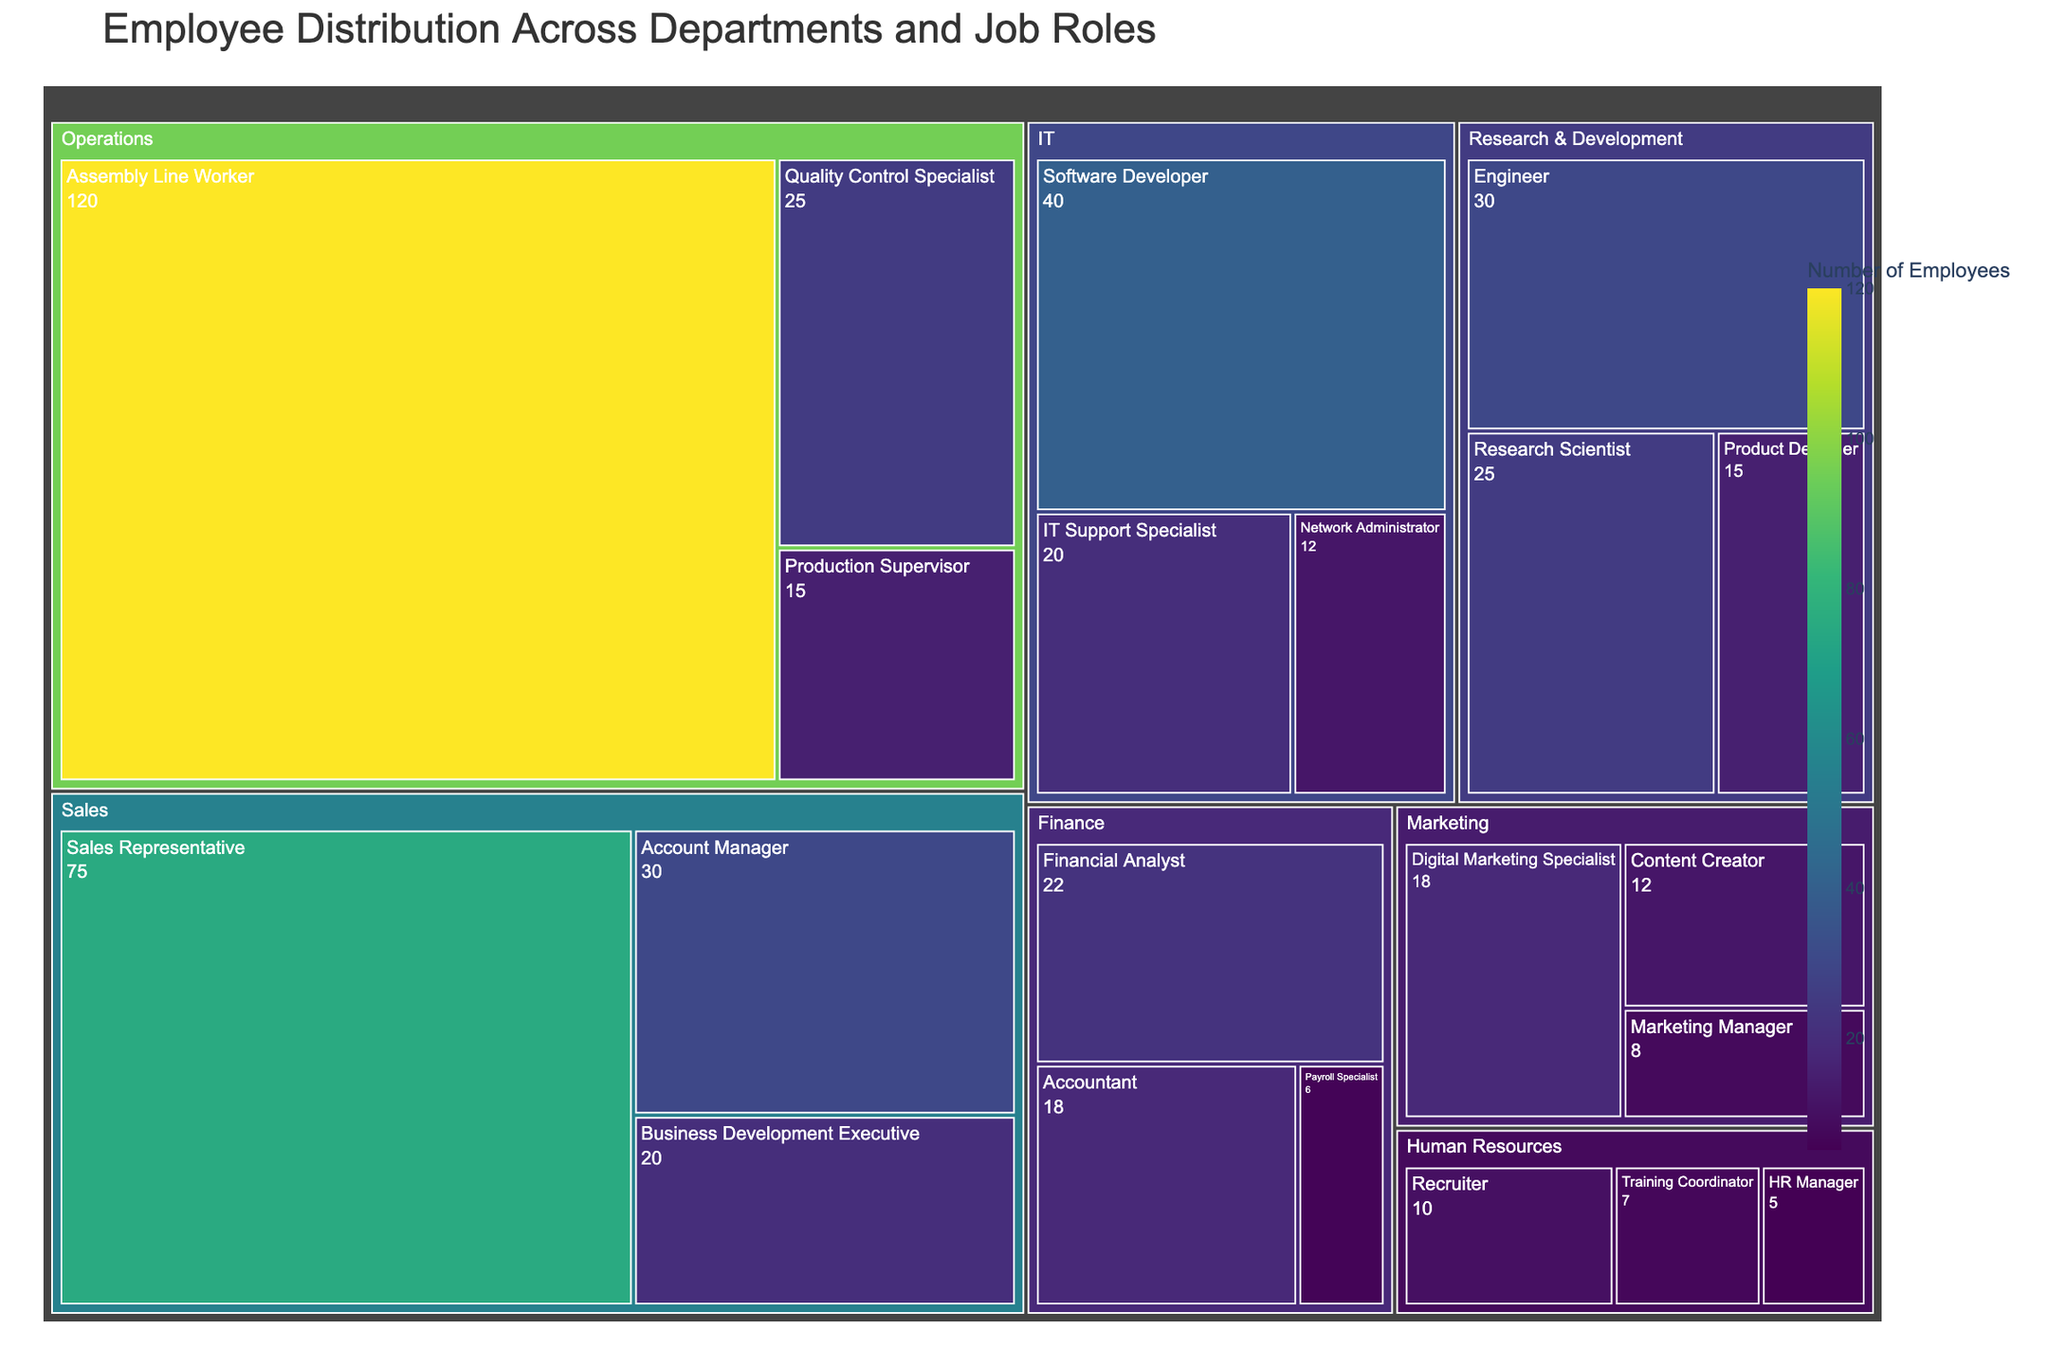What is the title of the treemap? The title of the treemap is displayed at the top of the figure and provides a summary of what the figure represents.
Answer: Employee Distribution Across Departments and Job Roles Which department has the highest number of employees? To find the department with the highest number of employees, look for the largest "block" size associated with each department label.
Answer: Operations How many Marketing Managers are there in the company? Find the block labeled "Marketing Manager" under the Marketing department and read the number of employees displayed.
Answer: 8 What is the total number of employees in the Sales department? Sum the number of employees for all job roles under the Sales department: 30 (Account Manager) + 75 (Sales Representative) + 20 (Business Development Executive).
Answer: 125 Compare the number of employees in Content Creator and Payroll Specialist roles. Which has more employees? Find the blocks labeled "Content Creator" and "Payroll Specialist" and compare their displayed numbers. Content Creator has 12 employees, and Payroll Specialist has 6 employees.
Answer: Content Creator What is the total number of employees across all departments? Sum the number of employees for all job roles across departments to get the total: 15 + 120 + 25 + 30 + 75 + 20 + 8 + 18 + 12 + 22 + 18 + 6 + 5 + 10 + 7 + 40 + 12 + 20 + 25 + 15 + 30
Answer: 533 Which department has the least number of employees? Look for the smallest "block" size associated with each department label. Compare the sizes to identify the smallest one.
Answer: Human Resources How many job roles are there in the IT department? Count the number of distinct block labels under the IT department.
Answer: 3 Compare the number of employees in the Operations and Finance departments. Which department has more workers and by how many? Sum the number of employees in each department and then subtract to find the difference. Operations: 160 (15+120+25), Finance: 46 (22+18+6). Operations has more employees by 160 - 46.
Answer: Operations, by 114 Which department has the most diverse range of job roles? Count the number of distinct job roles under each department and compare the counts. Operations: 3, Sales: 3, Marketing: 3, Finance: 3, Human Resources: 3, IT: 3, Research & Development: 3.
Answer: All departments have 3 job roles each 